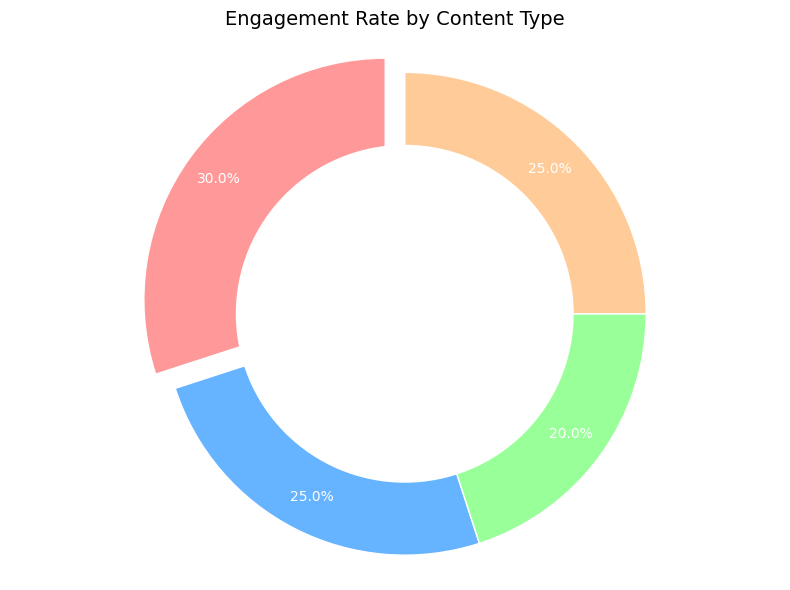What type of content has the highest engagement rate? The figure shows that "Fashion Tips" has the largest slice of the pie chart, indicating the highest engagement rate.
Answer: Fashion Tips Which two types of content have an equal engagement rate? By examining the pie chart, "Vintage Tutorials" and "Sponsored Content" both have slices of the same size, showing they have the same engagement rate.
Answer: Vintage Tutorials, Sponsored Content Compare the engagement rates of "Personal Stories" and "Fashion Tips". Which is more engaging? "Fashion Tips" has a larger slice (30%) compared to "Personal Stories" (20%), indicating it is more engaging.
Answer: Fashion Tips What percentage of the engagement does "Vintage Tutorials" and "Sponsored Content" contribute together? Both "Vintage Tutorials" and "Sponsored Content" contribute 25% each. Adding these together, 25% + 25% = 50%.
Answer: 50% What is the visual indication that emphasizes "Fashion Tips" in the pie chart? "Fashion Tips" is visually emphasized by having its slice slightly separated or 'exploded' from the rest of the pie.
Answer: It is 'exploded' Is the engagement rate of "Personal Stories" greater or less than "Sponsored Content"? The engagement rate of "Personal Stories" (20%) is less than that of "Sponsored Content" (25%) as indicated by its smaller slice in the pie chart.
Answer: Less What is the total engagement rate of all content types combined, and what does this indicate about the pie chart distribution percentages? The sum of engagement rates (30% + 25% + 20% + 25%) is 100%, which indicates that the distribution percentages in the pie chart are logically consistent to represent the whole dataset.
Answer: 100% If the engagement rate for "Vintage Tutorials" increased by 5%, how would this compare to "Fashion Tips"? The new rate for "Vintage Tutorials" would be 25% + 5% = 30%, making it equal to the current engagement rate of "Fashion Tips".
Answer: Equal Which content type is represented by the green color in the pie chart, based on the description of the colors used? According to the color-coding, the green slice in the pie chart corresponds to "Personal Stories".
Answer: Personal Stories 